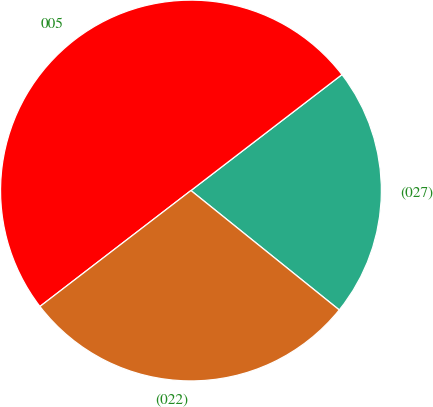Convert chart. <chart><loc_0><loc_0><loc_500><loc_500><pie_chart><fcel>(027)<fcel>005<fcel>(022)<nl><fcel>21.21%<fcel>50.0%<fcel>28.79%<nl></chart> 